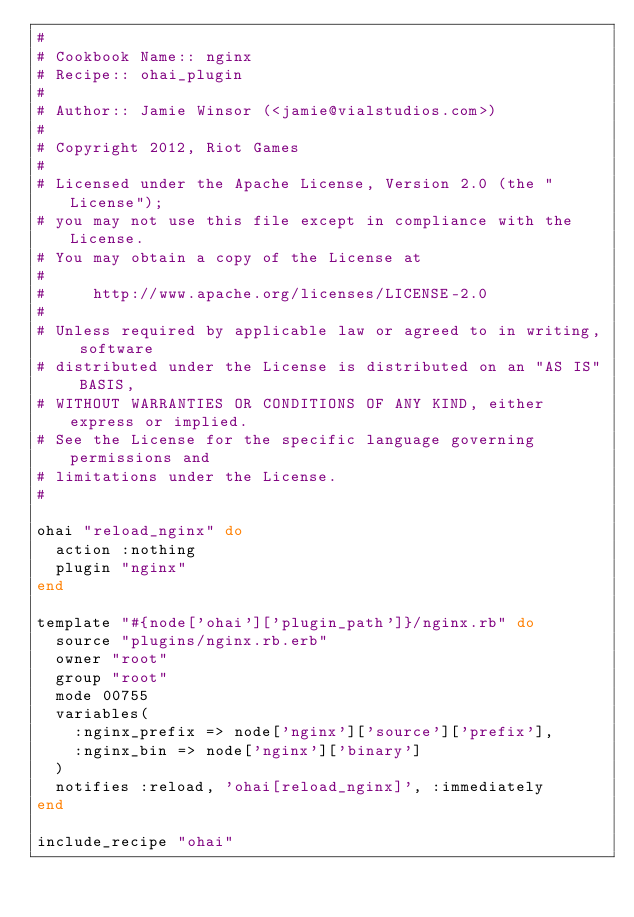Convert code to text. <code><loc_0><loc_0><loc_500><loc_500><_Ruby_>#
# Cookbook Name:: nginx
# Recipe:: ohai_plugin
#
# Author:: Jamie Winsor (<jamie@vialstudios.com>)
#
# Copyright 2012, Riot Games
#
# Licensed under the Apache License, Version 2.0 (the "License");
# you may not use this file except in compliance with the License.
# You may obtain a copy of the License at
#
#     http://www.apache.org/licenses/LICENSE-2.0
#
# Unless required by applicable law or agreed to in writing, software
# distributed under the License is distributed on an "AS IS" BASIS,
# WITHOUT WARRANTIES OR CONDITIONS OF ANY KIND, either express or implied.
# See the License for the specific language governing permissions and
# limitations under the License.
#

ohai "reload_nginx" do
  action :nothing
  plugin "nginx"
end

template "#{node['ohai']['plugin_path']}/nginx.rb" do
  source "plugins/nginx.rb.erb"
  owner "root"
  group "root"
  mode 00755
  variables(
    :nginx_prefix => node['nginx']['source']['prefix'],
    :nginx_bin => node['nginx']['binary']
  )
  notifies :reload, 'ohai[reload_nginx]', :immediately
end

include_recipe "ohai"
</code> 